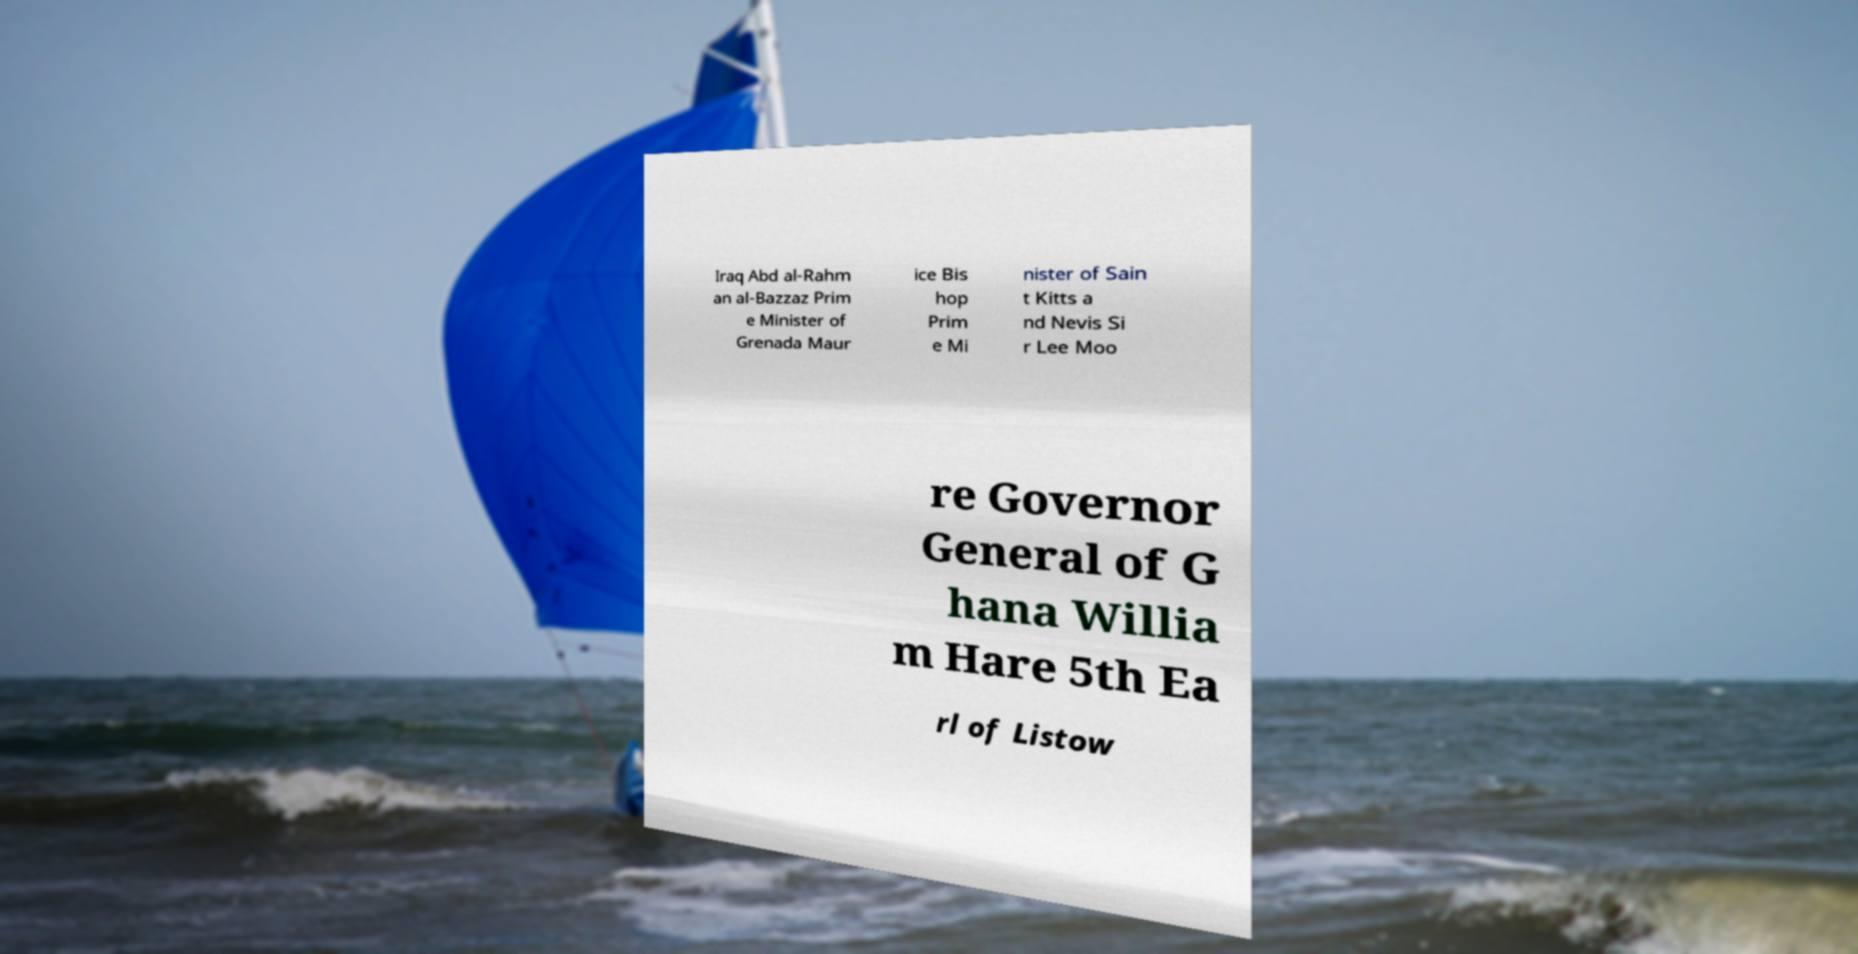Can you read and provide the text displayed in the image?This photo seems to have some interesting text. Can you extract and type it out for me? Iraq Abd al-Rahm an al-Bazzaz Prim e Minister of Grenada Maur ice Bis hop Prim e Mi nister of Sain t Kitts a nd Nevis Si r Lee Moo re Governor General of G hana Willia m Hare 5th Ea rl of Listow 